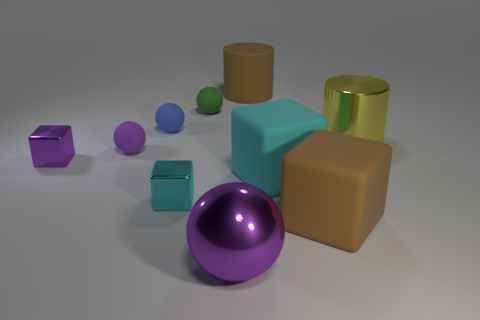How many purple spheres must be subtracted to get 1 purple spheres? 1 Subtract all purple blocks. How many blocks are left? 3 Subtract all tiny purple metallic blocks. How many blocks are left? 3 Subtract all cylinders. How many objects are left? 8 Subtract 4 blocks. How many blocks are left? 0 Subtract all green blocks. How many blue balls are left? 1 Subtract 2 purple balls. How many objects are left? 8 Subtract all gray blocks. Subtract all gray spheres. How many blocks are left? 4 Subtract all small gray balls. Subtract all cyan rubber cubes. How many objects are left? 9 Add 1 purple rubber things. How many purple rubber things are left? 2 